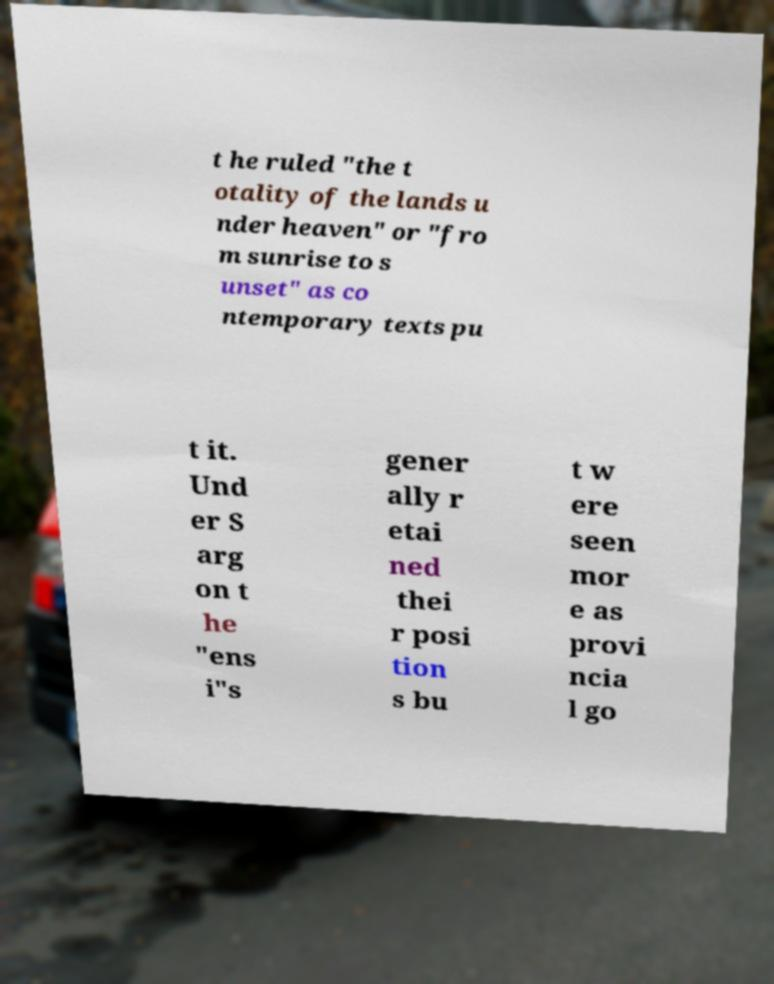Please identify and transcribe the text found in this image. t he ruled "the t otality of the lands u nder heaven" or "fro m sunrise to s unset" as co ntemporary texts pu t it. Und er S arg on t he "ens i"s gener ally r etai ned thei r posi tion s bu t w ere seen mor e as provi ncia l go 